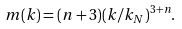Convert formula to latex. <formula><loc_0><loc_0><loc_500><loc_500>m ( k ) = ( n + 3 ) ( k / k _ { N } ) ^ { 3 + n } .</formula> 